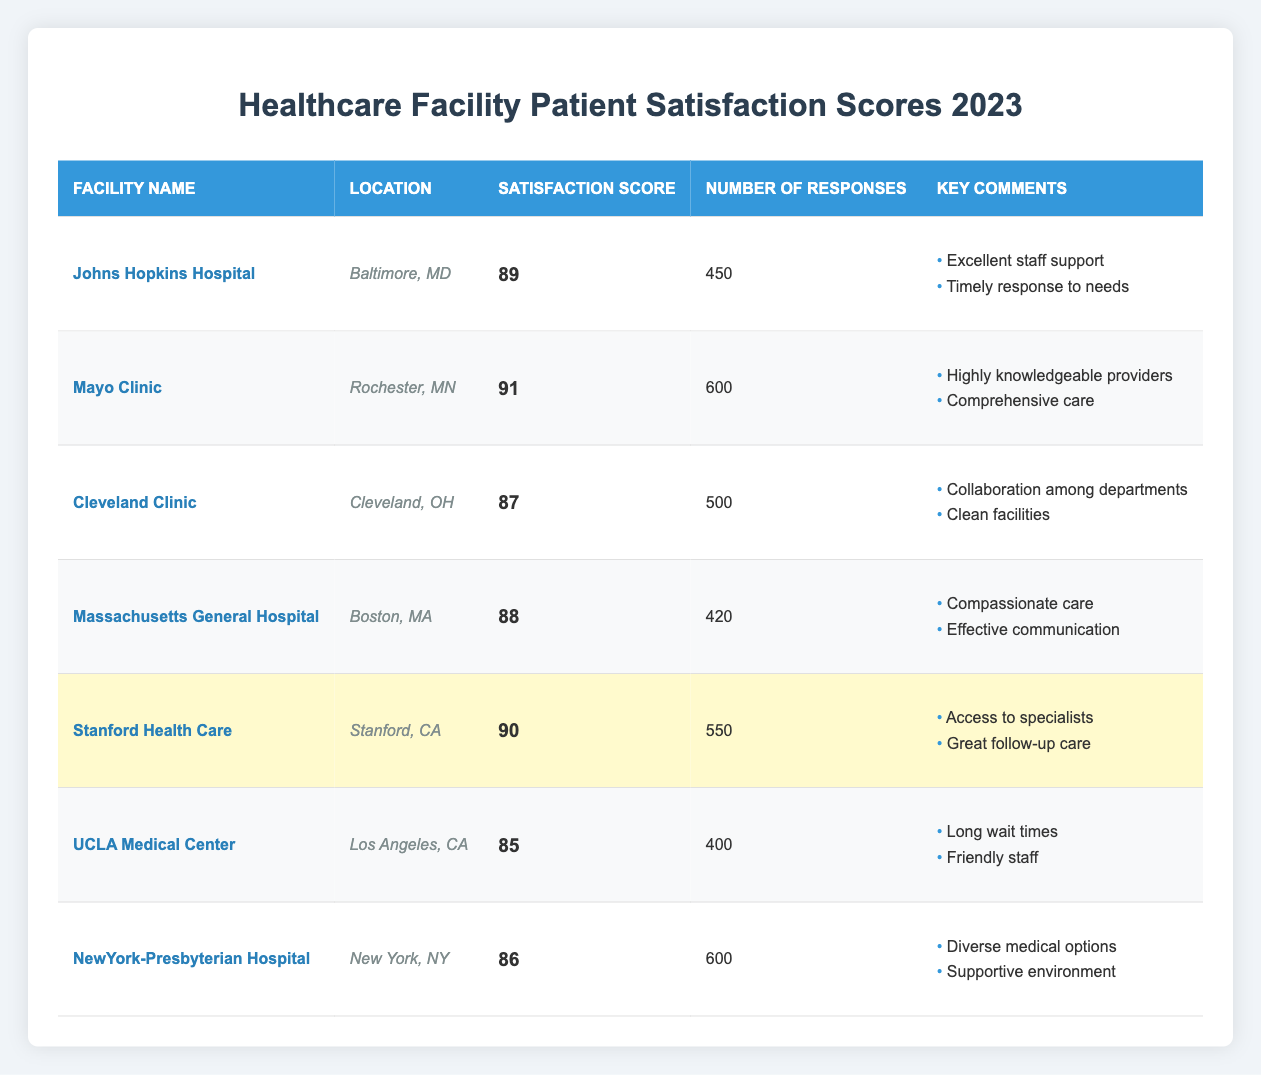What is the patient satisfaction score of Mayo Clinic? The patient satisfaction score for Mayo Clinic is listed directly in the table under the "Satisfaction Score" column. It shows a score of 91.
Answer: 91 Which facility has the highest patient satisfaction score? The table shows that Mayo Clinic has the highest patient satisfaction score of 91, which can be found by comparing the scores of all the facilities listed.
Answer: Mayo Clinic How many responses were received for UCLA Medical Center? The number of responses for UCLA Medical Center is displayed in the corresponding row under the "Number of Responses" column. It indicates a total of 400 responses.
Answer: 400 What is the average patient satisfaction score of all listed facilities? First, add the scores: (89 + 91 + 87 + 88 + 90 + 85 + 86) = 516. Then, divide by the number of facilities (7): 516/7 = 73.71 (rounded to the nearest whole number is 74).
Answer: 74 Which facility received the lowest patient satisfaction score? By examining the "Satisfaction Score" column in the table, UCLA Medical Center has the lowest score of 85, as it's the smallest number listed.
Answer: UCLA Medical Center Is the patient satisfaction score for Massachusetts General Hospital above 85? The patient satisfaction score for Massachusetts General Hospital is 88, which is greater than 85. This can be verified by observing the score in the table.
Answer: Yes What is the total number of responses from Johns Hopkins Hospital and Cleveland Clinic combined? Add the number of responses from Johns Hopkins Hospital (450) and Cleveland Clinic (500): 450 + 500 = 950.
Answer: 950 Which facility has the highest number of responses, and what is that number? Reviewing the "Number of Responses" column, Mayo Clinic has the highest number of responses with 600.
Answer: Mayo Clinic, 600 Are there any facilities that received a satisfaction score of 90 or above? Checking the "Satisfaction Score" column reveals that both Mayo Clinic (91) and Stanford Health Care (90) achieved scores of 90 or above.
Answer: Yes What patient satisfaction score did NewYork-Presbyterian Hospital receive? The score for NewYork-Presbyterian Hospital is located in the "Satisfaction Score" column; it shows a score of 86.
Answer: 86 